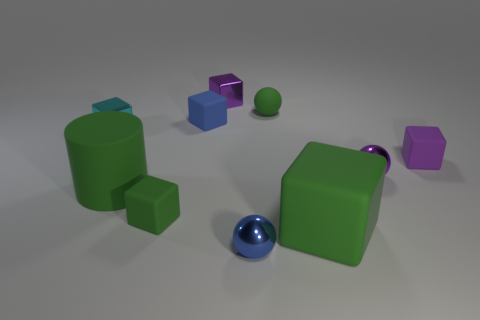Subtract all metallic spheres. How many spheres are left? 1 Subtract all cyan cubes. How many cubes are left? 5 Subtract 2 cubes. How many cubes are left? 4 Subtract all red cylinders. Subtract all yellow cubes. How many cylinders are left? 1 Subtract all yellow blocks. How many brown cylinders are left? 0 Subtract all small green balls. Subtract all purple cubes. How many objects are left? 7 Add 7 small purple things. How many small purple things are left? 10 Add 1 small blue rubber blocks. How many small blue rubber blocks exist? 2 Subtract 0 yellow spheres. How many objects are left? 10 Subtract all blocks. How many objects are left? 4 